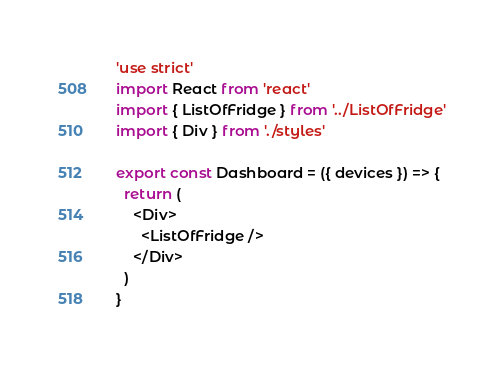<code> <loc_0><loc_0><loc_500><loc_500><_JavaScript_>'use strict'
import React from 'react'
import { ListOfFridge } from '../ListOfFridge'
import { Div } from './styles'

export const Dashboard = ({ devices }) => {
  return (
    <Div>
      <ListOfFridge />
    </Div>
  )
}
</code> 